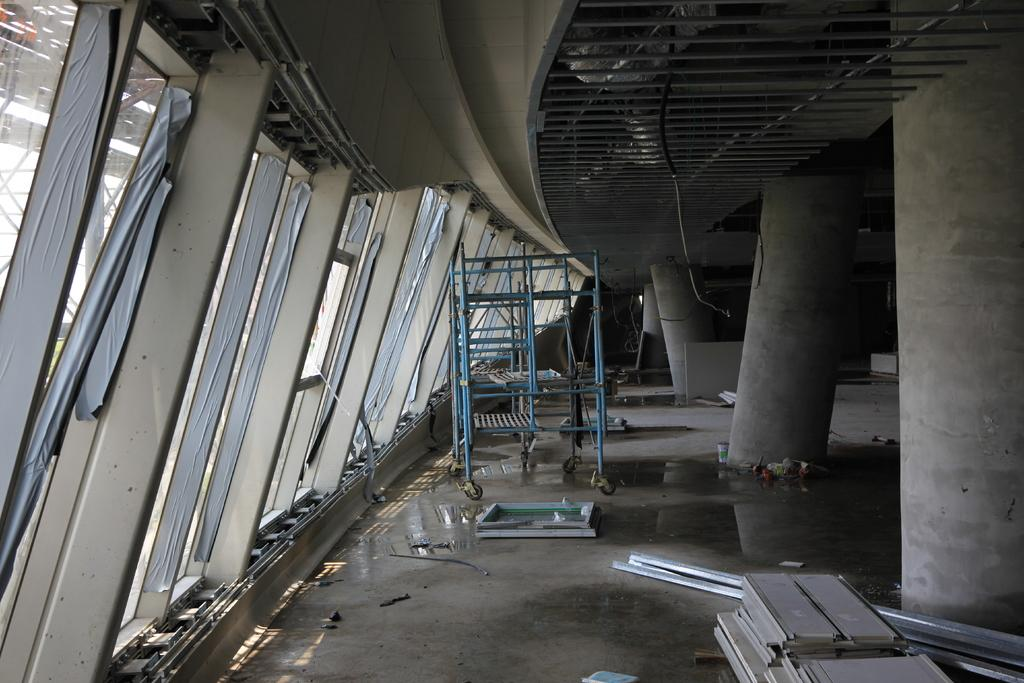What type of architectural feature can be seen in the image? There are pillars in the image. Where are the pillars located? The pillars are part of a rooftop in the image. What material is used for the rods in the image? Metal rods are visible in the image. What is the wheel stand used for? The wheel stand is likely used for supporting or holding a wheel, such as a bicycle wheel. Can you determine the time of day when the image was taken? The image was likely taken during the day, as there is sufficient light to see the details clearly. Are there any cherries hanging from the pillars in the image? There are no cherries present in the image; it features pillars, a rooftop, metal rods, a wheel stand, and a likely daytime setting. Is the celery used as a decorative element on the rooftop in the image? There is no celery present in the image; it only features pillars, a rooftop, metal rods, a wheel stand, and a likely daytime setting. 